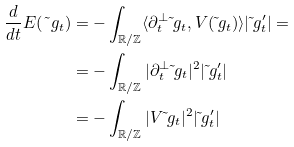Convert formula to latex. <formula><loc_0><loc_0><loc_500><loc_500>\frac { d } { d t } E ( \tilde { \ } g _ { t } ) & = - \int _ { \mathbb { R } / \mathbb { Z } } \langle \partial _ { t } ^ { \bot } \tilde { \ } g _ { t } , V ( \tilde { \ } g _ { t } ) \rangle | \tilde { \ } g _ { t } ^ { \prime } | = \\ & = - \int _ { \mathbb { R } / \mathbb { Z } } | \partial _ { t } ^ { \bot } \tilde { \ } g _ { t } | ^ { 2 } | \tilde { \ } g _ { t } ^ { \prime } | \\ & = - \int _ { \mathbb { R } / \mathbb { Z } } | V \tilde { \ } g _ { t } | ^ { 2 } | \tilde { \ } g _ { t } ^ { \prime } |</formula> 